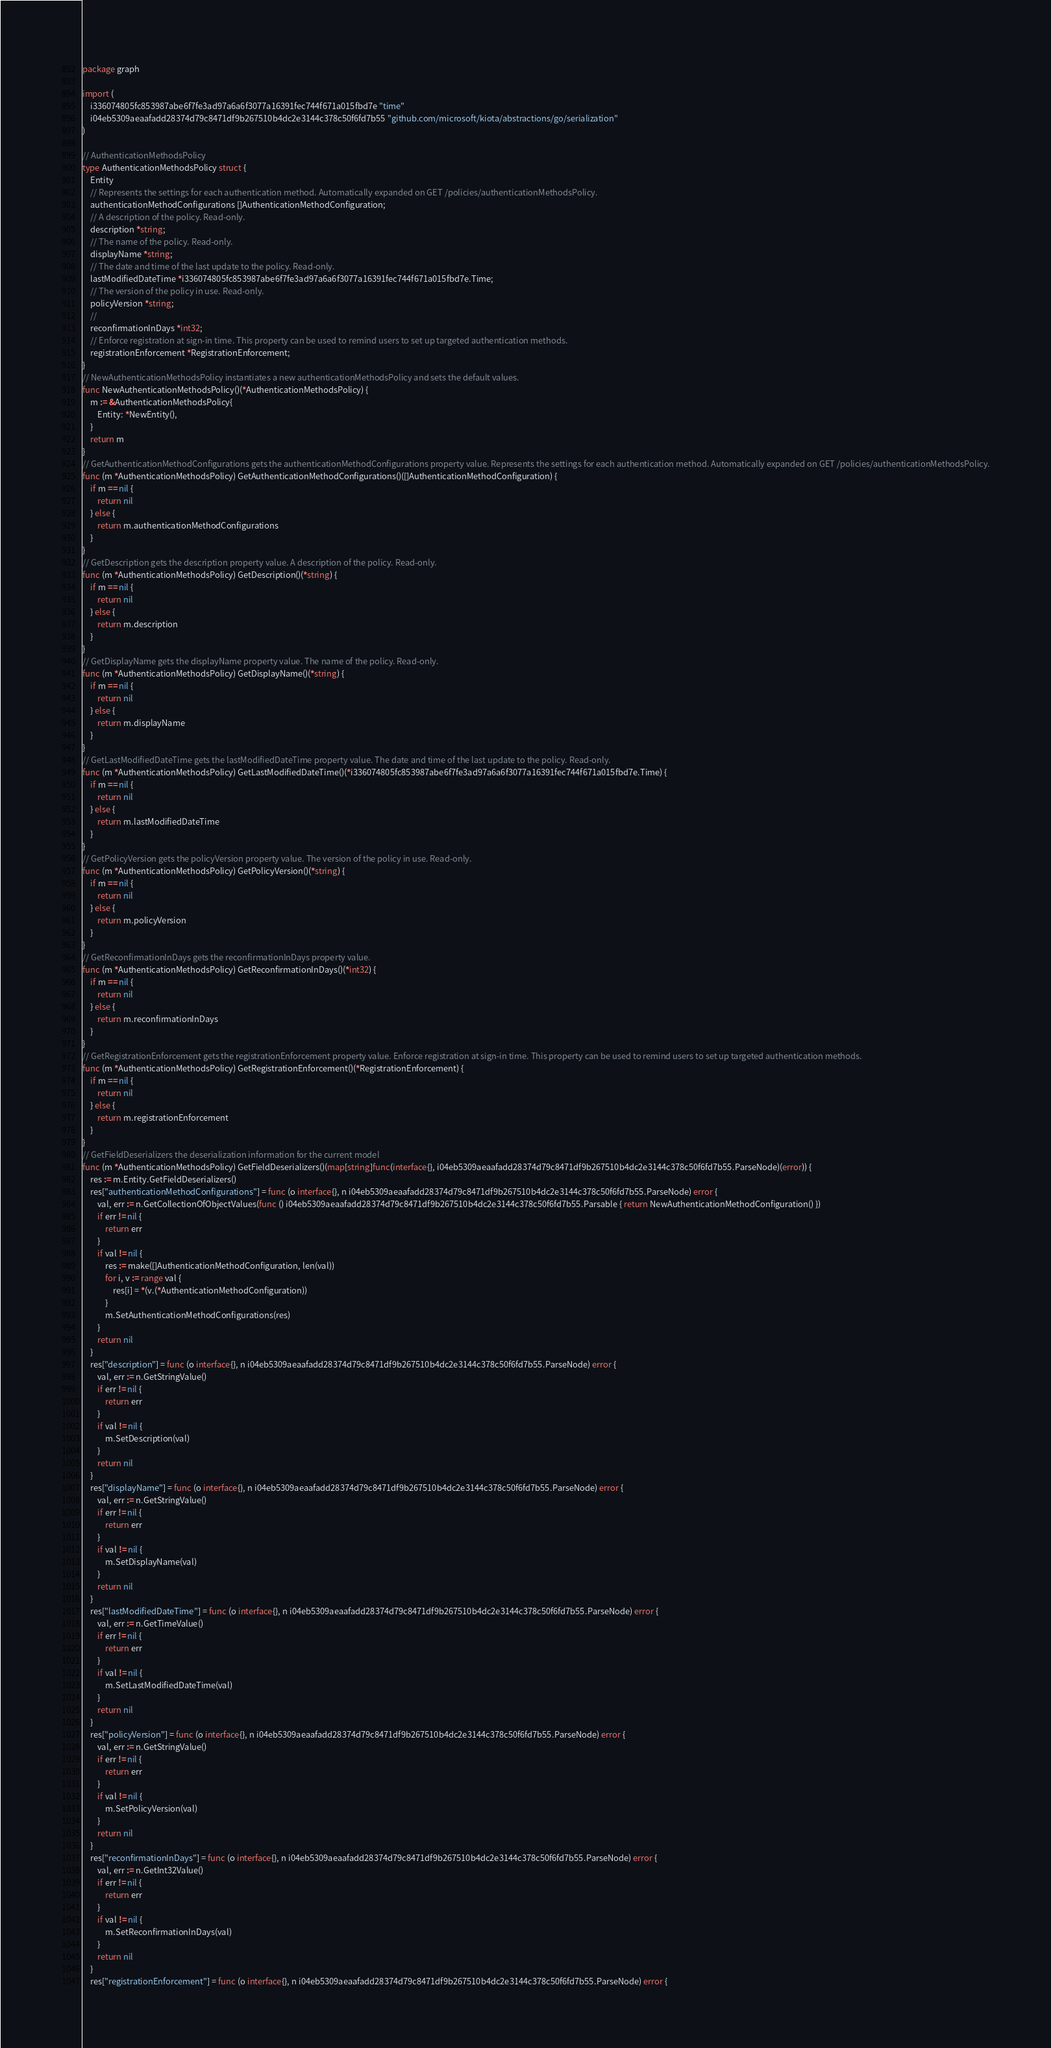Convert code to text. <code><loc_0><loc_0><loc_500><loc_500><_Go_>package graph

import (
    i336074805fc853987abe6f7fe3ad97a6a6f3077a16391fec744f671a015fbd7e "time"
    i04eb5309aeaafadd28374d79c8471df9b267510b4dc2e3144c378c50f6fd7b55 "github.com/microsoft/kiota/abstractions/go/serialization"
)

// AuthenticationMethodsPolicy 
type AuthenticationMethodsPolicy struct {
    Entity
    // Represents the settings for each authentication method. Automatically expanded on GET /policies/authenticationMethodsPolicy.
    authenticationMethodConfigurations []AuthenticationMethodConfiguration;
    // A description of the policy. Read-only.
    description *string;
    // The name of the policy. Read-only.
    displayName *string;
    // The date and time of the last update to the policy. Read-only.
    lastModifiedDateTime *i336074805fc853987abe6f7fe3ad97a6a6f3077a16391fec744f671a015fbd7e.Time;
    // The version of the policy in use. Read-only.
    policyVersion *string;
    // 
    reconfirmationInDays *int32;
    // Enforce registration at sign-in time. This property can be used to remind users to set up targeted authentication methods.
    registrationEnforcement *RegistrationEnforcement;
}
// NewAuthenticationMethodsPolicy instantiates a new authenticationMethodsPolicy and sets the default values.
func NewAuthenticationMethodsPolicy()(*AuthenticationMethodsPolicy) {
    m := &AuthenticationMethodsPolicy{
        Entity: *NewEntity(),
    }
    return m
}
// GetAuthenticationMethodConfigurations gets the authenticationMethodConfigurations property value. Represents the settings for each authentication method. Automatically expanded on GET /policies/authenticationMethodsPolicy.
func (m *AuthenticationMethodsPolicy) GetAuthenticationMethodConfigurations()([]AuthenticationMethodConfiguration) {
    if m == nil {
        return nil
    } else {
        return m.authenticationMethodConfigurations
    }
}
// GetDescription gets the description property value. A description of the policy. Read-only.
func (m *AuthenticationMethodsPolicy) GetDescription()(*string) {
    if m == nil {
        return nil
    } else {
        return m.description
    }
}
// GetDisplayName gets the displayName property value. The name of the policy. Read-only.
func (m *AuthenticationMethodsPolicy) GetDisplayName()(*string) {
    if m == nil {
        return nil
    } else {
        return m.displayName
    }
}
// GetLastModifiedDateTime gets the lastModifiedDateTime property value. The date and time of the last update to the policy. Read-only.
func (m *AuthenticationMethodsPolicy) GetLastModifiedDateTime()(*i336074805fc853987abe6f7fe3ad97a6a6f3077a16391fec744f671a015fbd7e.Time) {
    if m == nil {
        return nil
    } else {
        return m.lastModifiedDateTime
    }
}
// GetPolicyVersion gets the policyVersion property value. The version of the policy in use. Read-only.
func (m *AuthenticationMethodsPolicy) GetPolicyVersion()(*string) {
    if m == nil {
        return nil
    } else {
        return m.policyVersion
    }
}
// GetReconfirmationInDays gets the reconfirmationInDays property value. 
func (m *AuthenticationMethodsPolicy) GetReconfirmationInDays()(*int32) {
    if m == nil {
        return nil
    } else {
        return m.reconfirmationInDays
    }
}
// GetRegistrationEnforcement gets the registrationEnforcement property value. Enforce registration at sign-in time. This property can be used to remind users to set up targeted authentication methods.
func (m *AuthenticationMethodsPolicy) GetRegistrationEnforcement()(*RegistrationEnforcement) {
    if m == nil {
        return nil
    } else {
        return m.registrationEnforcement
    }
}
// GetFieldDeserializers the deserialization information for the current model
func (m *AuthenticationMethodsPolicy) GetFieldDeserializers()(map[string]func(interface{}, i04eb5309aeaafadd28374d79c8471df9b267510b4dc2e3144c378c50f6fd7b55.ParseNode)(error)) {
    res := m.Entity.GetFieldDeserializers()
    res["authenticationMethodConfigurations"] = func (o interface{}, n i04eb5309aeaafadd28374d79c8471df9b267510b4dc2e3144c378c50f6fd7b55.ParseNode) error {
        val, err := n.GetCollectionOfObjectValues(func () i04eb5309aeaafadd28374d79c8471df9b267510b4dc2e3144c378c50f6fd7b55.Parsable { return NewAuthenticationMethodConfiguration() })
        if err != nil {
            return err
        }
        if val != nil {
            res := make([]AuthenticationMethodConfiguration, len(val))
            for i, v := range val {
                res[i] = *(v.(*AuthenticationMethodConfiguration))
            }
            m.SetAuthenticationMethodConfigurations(res)
        }
        return nil
    }
    res["description"] = func (o interface{}, n i04eb5309aeaafadd28374d79c8471df9b267510b4dc2e3144c378c50f6fd7b55.ParseNode) error {
        val, err := n.GetStringValue()
        if err != nil {
            return err
        }
        if val != nil {
            m.SetDescription(val)
        }
        return nil
    }
    res["displayName"] = func (o interface{}, n i04eb5309aeaafadd28374d79c8471df9b267510b4dc2e3144c378c50f6fd7b55.ParseNode) error {
        val, err := n.GetStringValue()
        if err != nil {
            return err
        }
        if val != nil {
            m.SetDisplayName(val)
        }
        return nil
    }
    res["lastModifiedDateTime"] = func (o interface{}, n i04eb5309aeaafadd28374d79c8471df9b267510b4dc2e3144c378c50f6fd7b55.ParseNode) error {
        val, err := n.GetTimeValue()
        if err != nil {
            return err
        }
        if val != nil {
            m.SetLastModifiedDateTime(val)
        }
        return nil
    }
    res["policyVersion"] = func (o interface{}, n i04eb5309aeaafadd28374d79c8471df9b267510b4dc2e3144c378c50f6fd7b55.ParseNode) error {
        val, err := n.GetStringValue()
        if err != nil {
            return err
        }
        if val != nil {
            m.SetPolicyVersion(val)
        }
        return nil
    }
    res["reconfirmationInDays"] = func (o interface{}, n i04eb5309aeaafadd28374d79c8471df9b267510b4dc2e3144c378c50f6fd7b55.ParseNode) error {
        val, err := n.GetInt32Value()
        if err != nil {
            return err
        }
        if val != nil {
            m.SetReconfirmationInDays(val)
        }
        return nil
    }
    res["registrationEnforcement"] = func (o interface{}, n i04eb5309aeaafadd28374d79c8471df9b267510b4dc2e3144c378c50f6fd7b55.ParseNode) error {</code> 